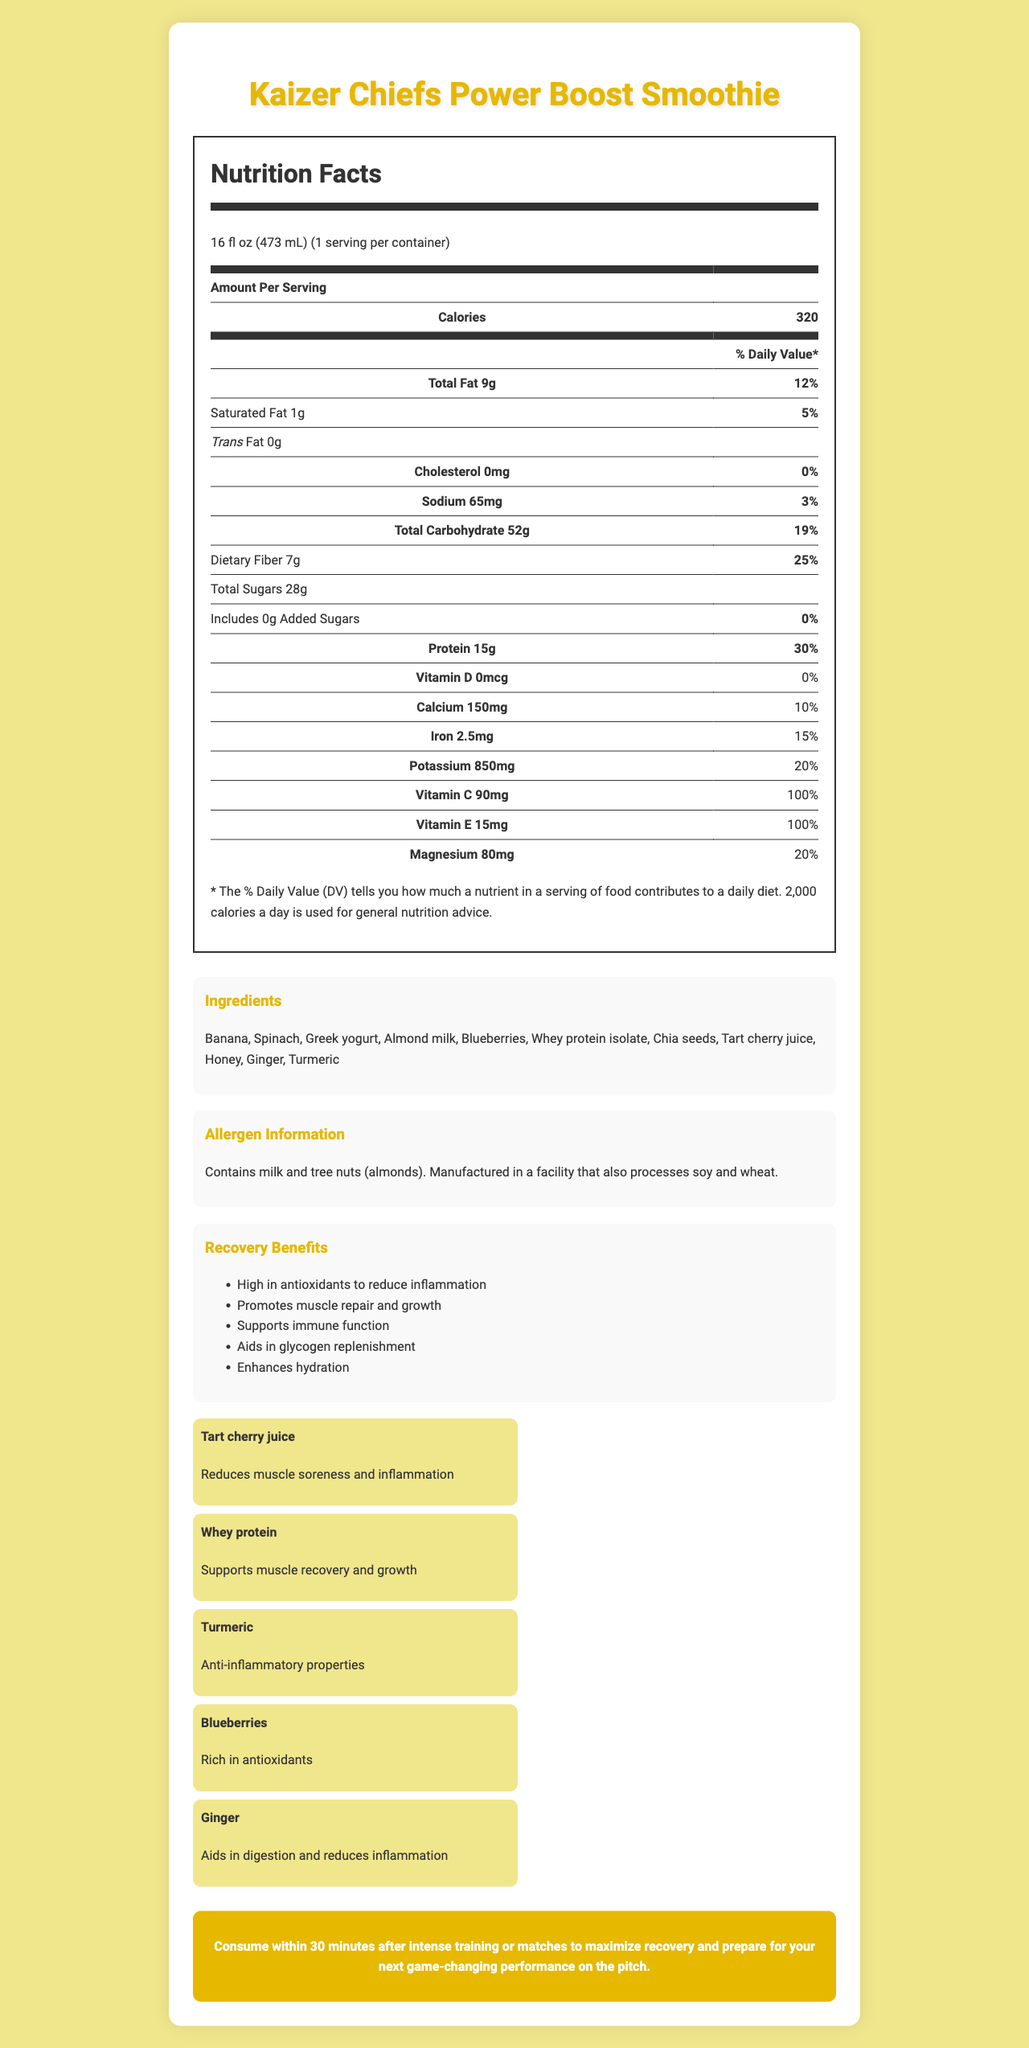what is the serving size of the Kaizer Chiefs Power Boost Smoothie? The serving size is listed at the top of the Nutrition Facts section of the document.
Answer: 16 fl oz (473 mL) how many calories are in one serving of the smoothie? The calories per serving are prominently displayed in the Nutrition Facts section.
Answer: 320 what is the amount of protein per serving, and what percentage of the daily value does it represent? The Nutrition Facts section shows the amount of protein as 15g, which represents 30% of the daily value.
Answer: 15g, 30% name three key ingredients that provide specific recovery benefits The key ingredients section details the specific benefits of each major ingredient, including tart cherry juice, whey protein, and turmeric for recovery and muscle health.
Answer: Tart cherry juice, Whey protein, Turmeric what are the total sugars included in the smoothie, and are there any added sugars? The total sugars are listed as 28g, and the section clearly states that there are no added sugars.
Answer: 28g, No added sugars (0g) are there any allergens present in the Kaizer Chiefs Power Boost Smoothie? The allergen information indicates that the smoothie contains milk and tree nuts (almonds).
Answer: Yes how much Vitamin C is in the smoothie, and what percentage of the daily value does this represent? The Vitamin C content is listed as 90mg, covering 100% of the daily value.
Answer: 90mg, 100% how much sodium is present in a serving of the smoothie? The Nutrition Facts section lists the sodium content as 65mg.
Answer: 65mg what is the primary source providing antioxidants in the smoothie? A. Banana B. Spinach C. Blueberries D. Ginger The key ingredients section mentions that blueberries are rich in antioxidants.
Answer: C. Blueberries which ingredient is known for its anti-inflammatory properties? I. Banana II. Turmeric III. Ginger IV. Almond milk Both the recovery benefits and the key ingredients section highlight turmeric for its anti-inflammatory properties.
Answer: II. Turmeric does the smoothie contain any cholesterol? The Nutrition Facts section lists the cholesterol content as 0mg, indicating none.
Answer: No summarize the main benefits and features of the Kaizer Chiefs Power Boost Smoothie The document details the nutritional content, key ingredients, allergen information, and the recovery benefits of the Kaizer Chiefs Power Boost Smoothie, emphasizing its role in muscle repair and overall health post-training.
Answer: The Kaizer Chiefs Power Boost Smoothie is a 16 fl oz (473 mL) serving packed with 320 calories, 15g of protein, and numerous vitamins and minerals. Key ingredients include tart cherry juice, whey protein, turmeric, blueberries, and ginger, which collectively provide benefits like muscle repair, reduced inflammation, and enhanced hydration. The smoothie contains no cholesterol, trans fat, or added sugars, but does include allergens such as milk and almonds. It is recommended to consume within 30 minutes post-training for optimal recovery. what is the exact amount of potassium mentioned in the document? The Nutrition Facts section lists the potassium content as 850mg.
Answer: 850mg how should the Kaizer Chiefs Power Boost Smoothie be consumed for maximum benefit? The performance tip at the end of the document advises consuming the smoothie within 30 minutes post-exercise for the best recovery results.
Answer: Within 30 minutes after intense training or matches what are the benefits provided by consumption of tart cherry juice according to the document? The key ingredients section states that tart cherry juice helps reduce muscle soreness and inflammation.
Answer: Reduces muscle soreness and inflammation is the smoothie intended for regular dietary use or after intense exercise? The recovery benefits and performance tip sections both suggest that the smoothie is designed to aid recovery after intense training or matches.
Answer: After intense exercise what is the recommended daily caloric intake used for general nutrition advice in the document? At the bottom of the Nutrition Facts section, it states that a 2,000 calorie daily diet is used for general nutrition advice.
Answer: 2,000 calories 